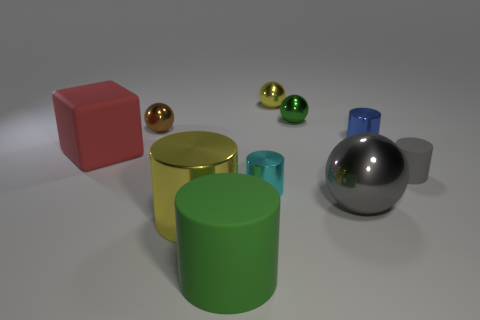Do the small cyan shiny object and the large green object have the same shape? yes 